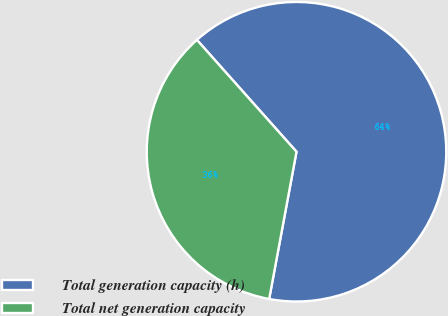<chart> <loc_0><loc_0><loc_500><loc_500><pie_chart><fcel>Total generation capacity (h)<fcel>Total net generation capacity<nl><fcel>64.5%<fcel>35.5%<nl></chart> 